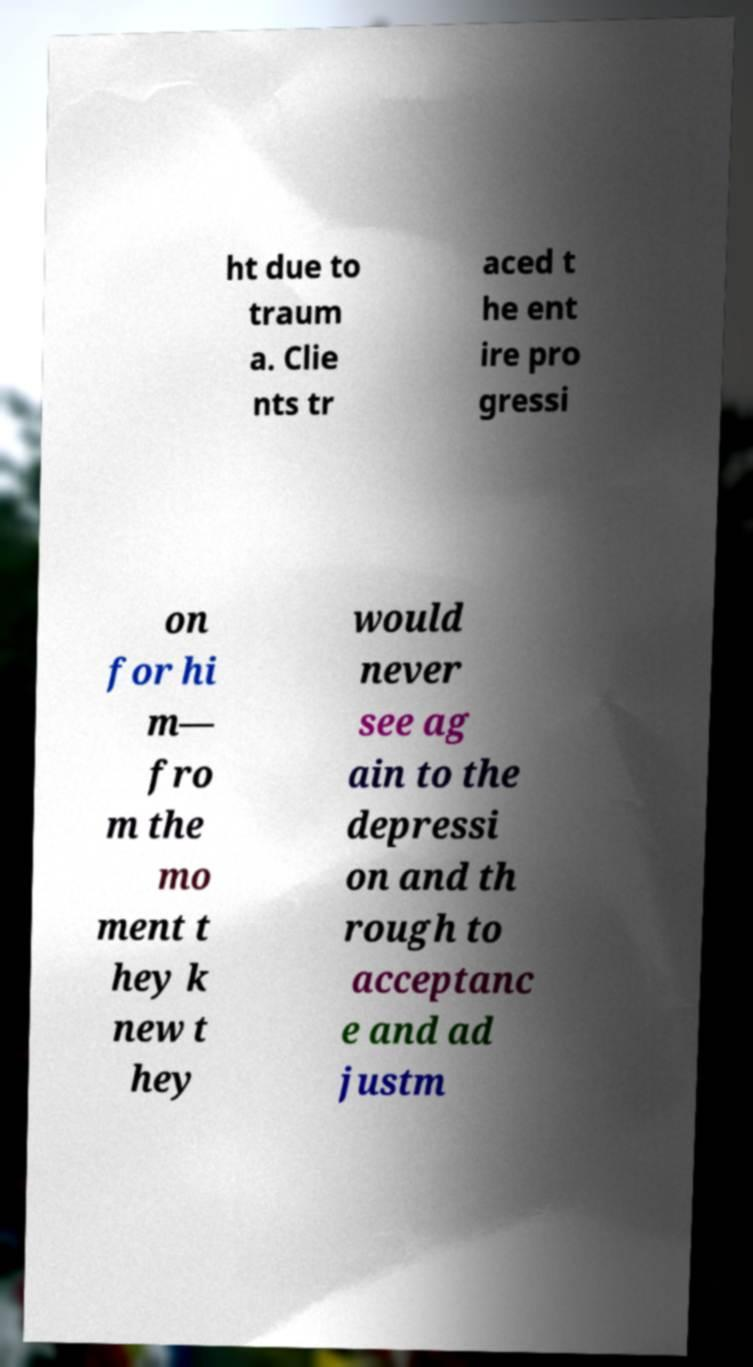Please read and relay the text visible in this image. What does it say? ht due to traum a. Clie nts tr aced t he ent ire pro gressi on for hi m— fro m the mo ment t hey k new t hey would never see ag ain to the depressi on and th rough to acceptanc e and ad justm 